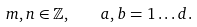<formula> <loc_0><loc_0><loc_500><loc_500>m , n \in { \mathbb { Z } } , \quad a , b = 1 \dots d .</formula> 